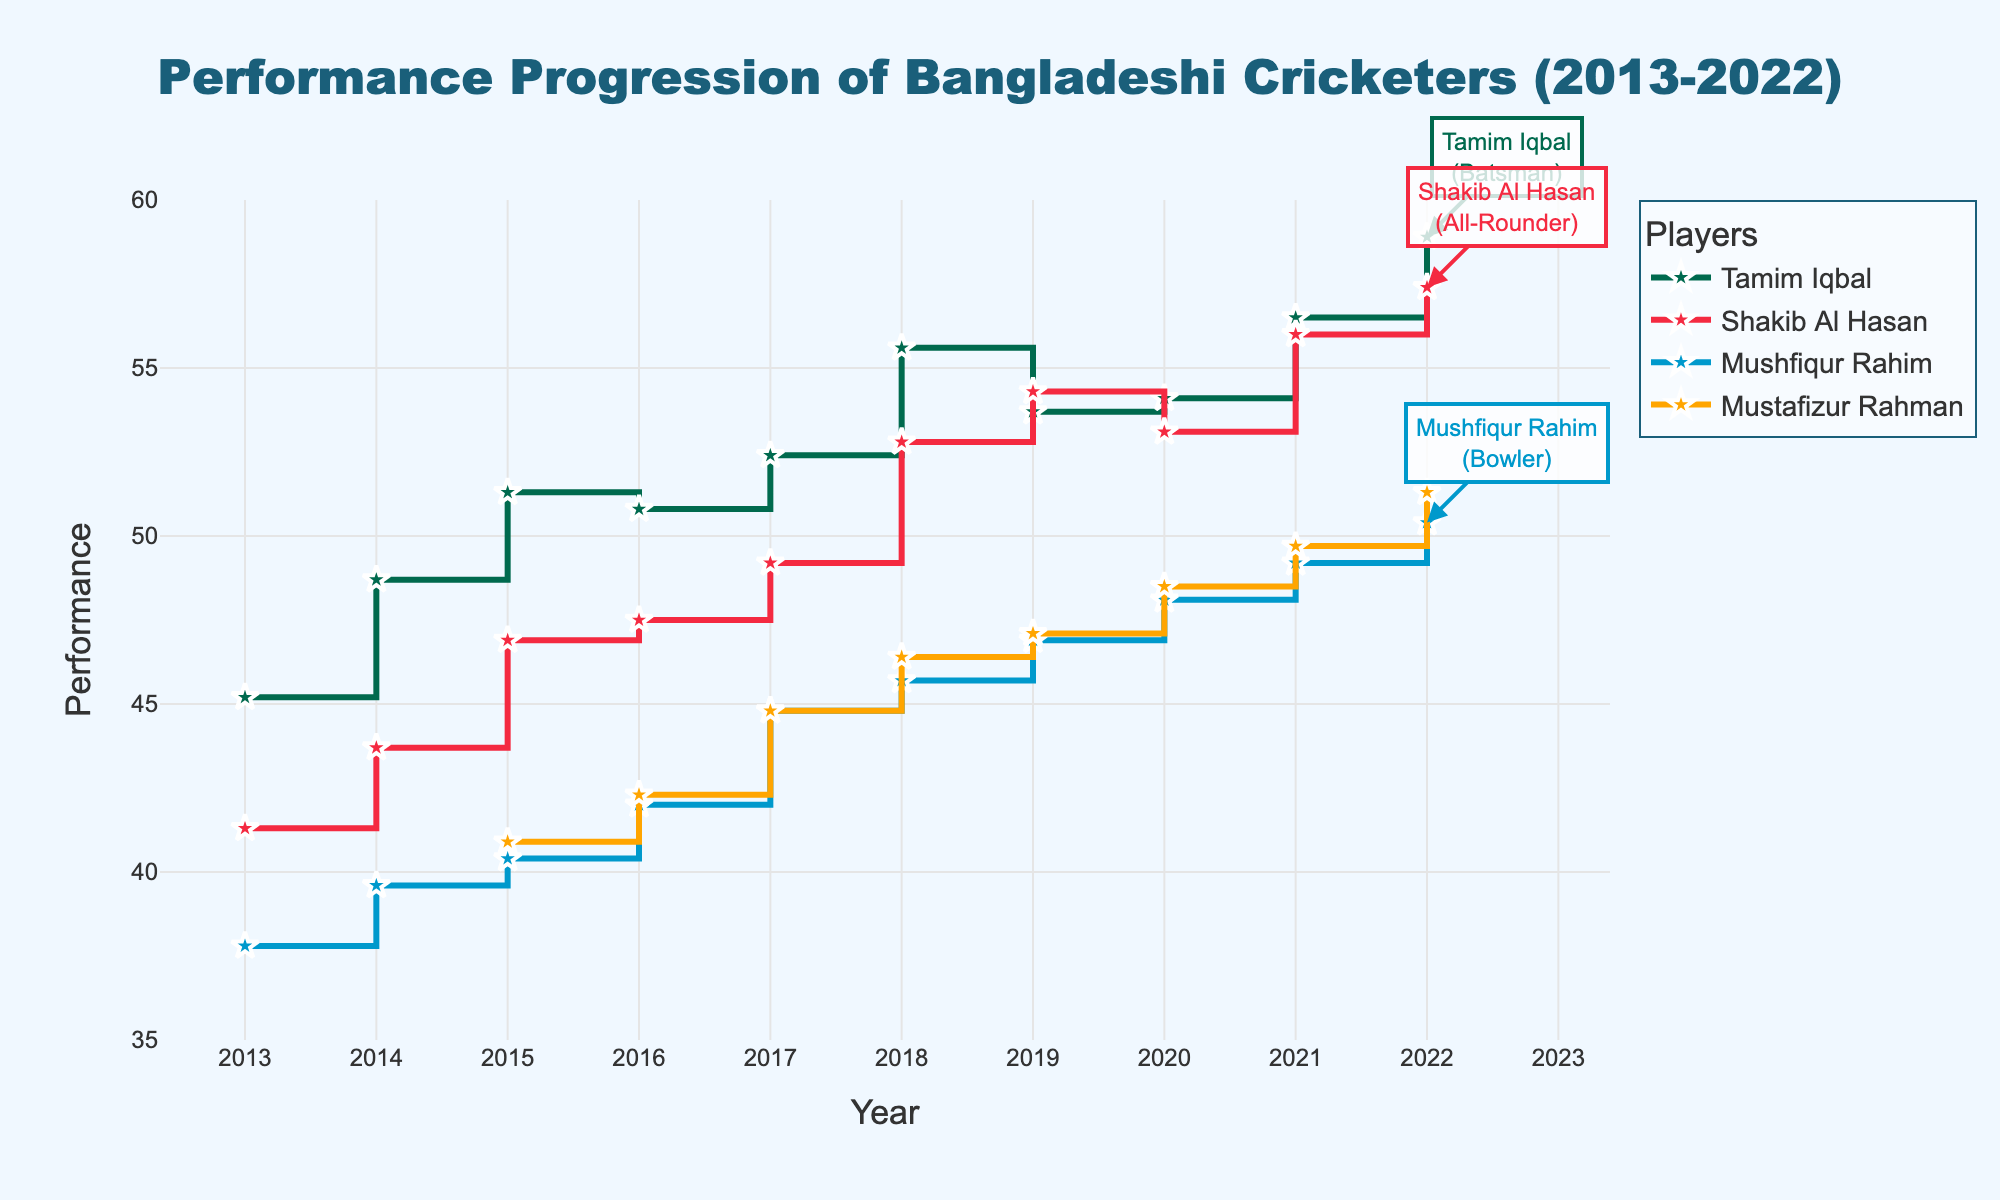What is the overall trend of Tamim Iqbal’s performance progression from 2013 to 2022? The plot shows Tamim Iqbal’s performance increasing from 45.2 in 2013 to 58.9 in 2022, despite slight drops in some years.
Answer: Increasing Who has the highest performance value in 2022? By inspecting the plot, Shakib Al Hasan has the highest performance with a value of 57.4 in 2022.
Answer: Shakib Al Hasan Compare the performance changes of Shakib Al Hasan and Mustafizur Rahman from 2015 to 2022. Shakib Al Hasan’s performance increased from 46.9 to 57.4, an increase of 10.5 points, whereas Mustafizur Rahman’s performance increased from 40.9 to 51.3, an increase of 10.4 points.
Answer: Shakib Al Hasan’s performance increased more comparably What is the range of performance values for Mushfiqur Rahim over the given period? The highest value for Mushfiqur Rahim is 50.4 in 2022 and the lowest is 37.8 in 2013, so the range is 50.4 - 37.8 = 12.6.
Answer: 12.6 How many years did Tamim Iqbal’s performance exceed 50? From the plot, Tamim Iqbal’s performance exceeded 50 from 2015 to 2022, resulting in 8 years.
Answer: 8 years Which player shows a consistent upward trend without any drop in performance over the years? Mustafizur Rahman shows a consistent upward trend from his entry in 2015 to 2022 without any drop.
Answer: Mustafizur Rahman Between 2019 and 2022, who had the largest performance improvement? By looking at the performance values, Tamim Iqbal improved from 53.7 to 58.9, an increase of 5.2 points, which is the largest compared to others in that period.
Answer: Tamim Iqbal How does Mushfiqur Rahim’s change in performance from 2013 to 2018 compare to Tamim Iqbal’s change in the same period? Mushfiqur Rahim’s performance increased from 37.8 to 45.7 (a change of 7.9), while Tamim Iqbal’s performance increased from 45.2 to 55.6 (a change of 10.4). Tamim Iqbal had a greater increase.
Answer: Tamim Iqbal had a greater increase What was the change in Shakib Al Hasan’s performance in the year 2020 compared to the previous year? Shakib Al Hasan’s performance in 2019 was 54.3, and in 2020 it was 53.1, hence the change was 53.1 - 54.3 = -1.2.
Answer: -1.2 